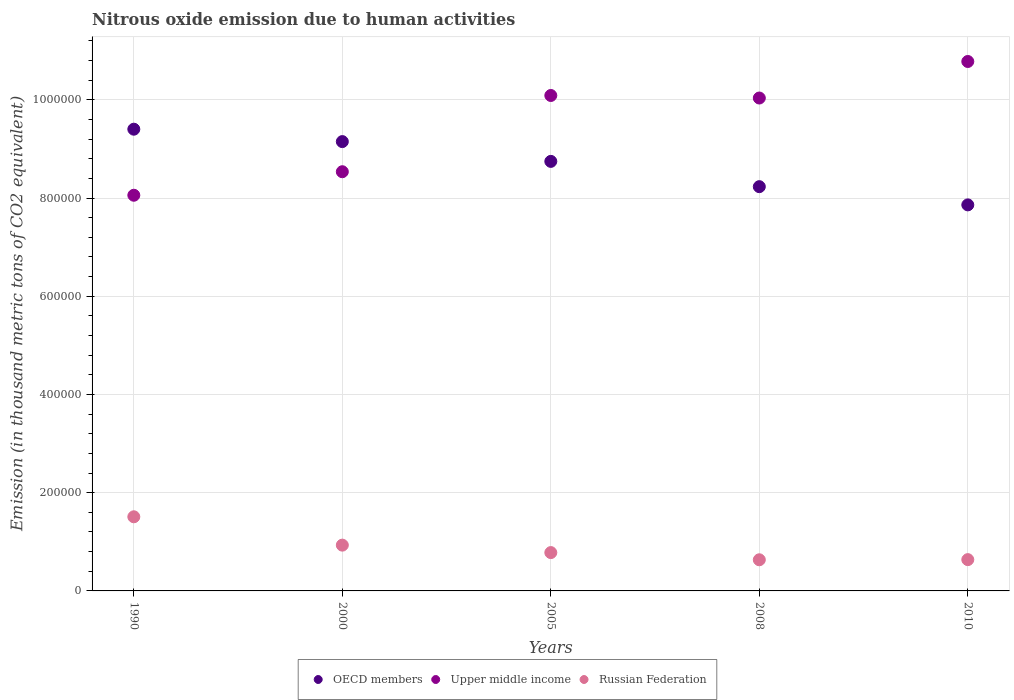What is the amount of nitrous oxide emitted in Russian Federation in 2000?
Offer a very short reply. 9.32e+04. Across all years, what is the maximum amount of nitrous oxide emitted in OECD members?
Your answer should be compact. 9.40e+05. Across all years, what is the minimum amount of nitrous oxide emitted in OECD members?
Keep it short and to the point. 7.86e+05. In which year was the amount of nitrous oxide emitted in Russian Federation maximum?
Ensure brevity in your answer.  1990. What is the total amount of nitrous oxide emitted in Russian Federation in the graph?
Offer a terse response. 4.49e+05. What is the difference between the amount of nitrous oxide emitted in Upper middle income in 2000 and that in 2010?
Offer a very short reply. -2.24e+05. What is the difference between the amount of nitrous oxide emitted in OECD members in 2000 and the amount of nitrous oxide emitted in Upper middle income in 2008?
Offer a terse response. -8.87e+04. What is the average amount of nitrous oxide emitted in Russian Federation per year?
Keep it short and to the point. 8.99e+04. In the year 2008, what is the difference between the amount of nitrous oxide emitted in Russian Federation and amount of nitrous oxide emitted in Upper middle income?
Provide a short and direct response. -9.40e+05. In how many years, is the amount of nitrous oxide emitted in Upper middle income greater than 240000 thousand metric tons?
Ensure brevity in your answer.  5. What is the ratio of the amount of nitrous oxide emitted in OECD members in 1990 to that in 2000?
Offer a very short reply. 1.03. Is the amount of nitrous oxide emitted in Upper middle income in 2000 less than that in 2008?
Provide a short and direct response. Yes. What is the difference between the highest and the second highest amount of nitrous oxide emitted in Upper middle income?
Offer a terse response. 6.92e+04. What is the difference between the highest and the lowest amount of nitrous oxide emitted in Russian Federation?
Your answer should be compact. 8.75e+04. In how many years, is the amount of nitrous oxide emitted in OECD members greater than the average amount of nitrous oxide emitted in OECD members taken over all years?
Provide a succinct answer. 3. Is it the case that in every year, the sum of the amount of nitrous oxide emitted in Russian Federation and amount of nitrous oxide emitted in OECD members  is greater than the amount of nitrous oxide emitted in Upper middle income?
Make the answer very short. No. Is the amount of nitrous oxide emitted in Upper middle income strictly greater than the amount of nitrous oxide emitted in OECD members over the years?
Give a very brief answer. No. How many dotlines are there?
Offer a very short reply. 3. Are the values on the major ticks of Y-axis written in scientific E-notation?
Provide a short and direct response. No. Does the graph contain any zero values?
Ensure brevity in your answer.  No. What is the title of the graph?
Provide a short and direct response. Nitrous oxide emission due to human activities. Does "Korea (Republic)" appear as one of the legend labels in the graph?
Provide a succinct answer. No. What is the label or title of the X-axis?
Offer a terse response. Years. What is the label or title of the Y-axis?
Your answer should be very brief. Emission (in thousand metric tons of CO2 equivalent). What is the Emission (in thousand metric tons of CO2 equivalent) in OECD members in 1990?
Your answer should be compact. 9.40e+05. What is the Emission (in thousand metric tons of CO2 equivalent) of Upper middle income in 1990?
Ensure brevity in your answer.  8.06e+05. What is the Emission (in thousand metric tons of CO2 equivalent) in Russian Federation in 1990?
Offer a terse response. 1.51e+05. What is the Emission (in thousand metric tons of CO2 equivalent) of OECD members in 2000?
Provide a short and direct response. 9.15e+05. What is the Emission (in thousand metric tons of CO2 equivalent) in Upper middle income in 2000?
Give a very brief answer. 8.54e+05. What is the Emission (in thousand metric tons of CO2 equivalent) of Russian Federation in 2000?
Your answer should be very brief. 9.32e+04. What is the Emission (in thousand metric tons of CO2 equivalent) in OECD members in 2005?
Make the answer very short. 8.75e+05. What is the Emission (in thousand metric tons of CO2 equivalent) in Upper middle income in 2005?
Give a very brief answer. 1.01e+06. What is the Emission (in thousand metric tons of CO2 equivalent) in Russian Federation in 2005?
Offer a very short reply. 7.81e+04. What is the Emission (in thousand metric tons of CO2 equivalent) in OECD members in 2008?
Keep it short and to the point. 8.23e+05. What is the Emission (in thousand metric tons of CO2 equivalent) of Upper middle income in 2008?
Ensure brevity in your answer.  1.00e+06. What is the Emission (in thousand metric tons of CO2 equivalent) of Russian Federation in 2008?
Provide a succinct answer. 6.34e+04. What is the Emission (in thousand metric tons of CO2 equivalent) in OECD members in 2010?
Provide a succinct answer. 7.86e+05. What is the Emission (in thousand metric tons of CO2 equivalent) in Upper middle income in 2010?
Ensure brevity in your answer.  1.08e+06. What is the Emission (in thousand metric tons of CO2 equivalent) of Russian Federation in 2010?
Your answer should be compact. 6.37e+04. Across all years, what is the maximum Emission (in thousand metric tons of CO2 equivalent) in OECD members?
Ensure brevity in your answer.  9.40e+05. Across all years, what is the maximum Emission (in thousand metric tons of CO2 equivalent) of Upper middle income?
Give a very brief answer. 1.08e+06. Across all years, what is the maximum Emission (in thousand metric tons of CO2 equivalent) of Russian Federation?
Keep it short and to the point. 1.51e+05. Across all years, what is the minimum Emission (in thousand metric tons of CO2 equivalent) in OECD members?
Give a very brief answer. 7.86e+05. Across all years, what is the minimum Emission (in thousand metric tons of CO2 equivalent) of Upper middle income?
Offer a very short reply. 8.06e+05. Across all years, what is the minimum Emission (in thousand metric tons of CO2 equivalent) in Russian Federation?
Ensure brevity in your answer.  6.34e+04. What is the total Emission (in thousand metric tons of CO2 equivalent) in OECD members in the graph?
Provide a short and direct response. 4.34e+06. What is the total Emission (in thousand metric tons of CO2 equivalent) of Upper middle income in the graph?
Give a very brief answer. 4.75e+06. What is the total Emission (in thousand metric tons of CO2 equivalent) in Russian Federation in the graph?
Make the answer very short. 4.49e+05. What is the difference between the Emission (in thousand metric tons of CO2 equivalent) of OECD members in 1990 and that in 2000?
Keep it short and to the point. 2.52e+04. What is the difference between the Emission (in thousand metric tons of CO2 equivalent) in Upper middle income in 1990 and that in 2000?
Provide a succinct answer. -4.79e+04. What is the difference between the Emission (in thousand metric tons of CO2 equivalent) in Russian Federation in 1990 and that in 2000?
Ensure brevity in your answer.  5.77e+04. What is the difference between the Emission (in thousand metric tons of CO2 equivalent) in OECD members in 1990 and that in 2005?
Make the answer very short. 6.55e+04. What is the difference between the Emission (in thousand metric tons of CO2 equivalent) in Upper middle income in 1990 and that in 2005?
Ensure brevity in your answer.  -2.03e+05. What is the difference between the Emission (in thousand metric tons of CO2 equivalent) of Russian Federation in 1990 and that in 2005?
Your response must be concise. 7.29e+04. What is the difference between the Emission (in thousand metric tons of CO2 equivalent) of OECD members in 1990 and that in 2008?
Offer a terse response. 1.17e+05. What is the difference between the Emission (in thousand metric tons of CO2 equivalent) in Upper middle income in 1990 and that in 2008?
Give a very brief answer. -1.98e+05. What is the difference between the Emission (in thousand metric tons of CO2 equivalent) of Russian Federation in 1990 and that in 2008?
Offer a very short reply. 8.75e+04. What is the difference between the Emission (in thousand metric tons of CO2 equivalent) in OECD members in 1990 and that in 2010?
Keep it short and to the point. 1.54e+05. What is the difference between the Emission (in thousand metric tons of CO2 equivalent) in Upper middle income in 1990 and that in 2010?
Your response must be concise. -2.72e+05. What is the difference between the Emission (in thousand metric tons of CO2 equivalent) of Russian Federation in 1990 and that in 2010?
Your answer should be compact. 8.72e+04. What is the difference between the Emission (in thousand metric tons of CO2 equivalent) of OECD members in 2000 and that in 2005?
Ensure brevity in your answer.  4.03e+04. What is the difference between the Emission (in thousand metric tons of CO2 equivalent) of Upper middle income in 2000 and that in 2005?
Make the answer very short. -1.55e+05. What is the difference between the Emission (in thousand metric tons of CO2 equivalent) of Russian Federation in 2000 and that in 2005?
Make the answer very short. 1.52e+04. What is the difference between the Emission (in thousand metric tons of CO2 equivalent) of OECD members in 2000 and that in 2008?
Make the answer very short. 9.18e+04. What is the difference between the Emission (in thousand metric tons of CO2 equivalent) in Upper middle income in 2000 and that in 2008?
Your answer should be very brief. -1.50e+05. What is the difference between the Emission (in thousand metric tons of CO2 equivalent) of Russian Federation in 2000 and that in 2008?
Your answer should be compact. 2.98e+04. What is the difference between the Emission (in thousand metric tons of CO2 equivalent) in OECD members in 2000 and that in 2010?
Ensure brevity in your answer.  1.29e+05. What is the difference between the Emission (in thousand metric tons of CO2 equivalent) in Upper middle income in 2000 and that in 2010?
Provide a succinct answer. -2.24e+05. What is the difference between the Emission (in thousand metric tons of CO2 equivalent) in Russian Federation in 2000 and that in 2010?
Ensure brevity in your answer.  2.95e+04. What is the difference between the Emission (in thousand metric tons of CO2 equivalent) of OECD members in 2005 and that in 2008?
Provide a short and direct response. 5.15e+04. What is the difference between the Emission (in thousand metric tons of CO2 equivalent) of Upper middle income in 2005 and that in 2008?
Your answer should be compact. 5159.9. What is the difference between the Emission (in thousand metric tons of CO2 equivalent) in Russian Federation in 2005 and that in 2008?
Keep it short and to the point. 1.46e+04. What is the difference between the Emission (in thousand metric tons of CO2 equivalent) in OECD members in 2005 and that in 2010?
Make the answer very short. 8.86e+04. What is the difference between the Emission (in thousand metric tons of CO2 equivalent) in Upper middle income in 2005 and that in 2010?
Give a very brief answer. -6.92e+04. What is the difference between the Emission (in thousand metric tons of CO2 equivalent) of Russian Federation in 2005 and that in 2010?
Provide a short and direct response. 1.43e+04. What is the difference between the Emission (in thousand metric tons of CO2 equivalent) of OECD members in 2008 and that in 2010?
Your answer should be very brief. 3.71e+04. What is the difference between the Emission (in thousand metric tons of CO2 equivalent) of Upper middle income in 2008 and that in 2010?
Give a very brief answer. -7.44e+04. What is the difference between the Emission (in thousand metric tons of CO2 equivalent) of Russian Federation in 2008 and that in 2010?
Offer a terse response. -319.3. What is the difference between the Emission (in thousand metric tons of CO2 equivalent) in OECD members in 1990 and the Emission (in thousand metric tons of CO2 equivalent) in Upper middle income in 2000?
Your answer should be compact. 8.66e+04. What is the difference between the Emission (in thousand metric tons of CO2 equivalent) in OECD members in 1990 and the Emission (in thousand metric tons of CO2 equivalent) in Russian Federation in 2000?
Offer a very short reply. 8.47e+05. What is the difference between the Emission (in thousand metric tons of CO2 equivalent) in Upper middle income in 1990 and the Emission (in thousand metric tons of CO2 equivalent) in Russian Federation in 2000?
Your answer should be very brief. 7.12e+05. What is the difference between the Emission (in thousand metric tons of CO2 equivalent) in OECD members in 1990 and the Emission (in thousand metric tons of CO2 equivalent) in Upper middle income in 2005?
Ensure brevity in your answer.  -6.86e+04. What is the difference between the Emission (in thousand metric tons of CO2 equivalent) of OECD members in 1990 and the Emission (in thousand metric tons of CO2 equivalent) of Russian Federation in 2005?
Ensure brevity in your answer.  8.62e+05. What is the difference between the Emission (in thousand metric tons of CO2 equivalent) of Upper middle income in 1990 and the Emission (in thousand metric tons of CO2 equivalent) of Russian Federation in 2005?
Your answer should be very brief. 7.28e+05. What is the difference between the Emission (in thousand metric tons of CO2 equivalent) of OECD members in 1990 and the Emission (in thousand metric tons of CO2 equivalent) of Upper middle income in 2008?
Provide a short and direct response. -6.35e+04. What is the difference between the Emission (in thousand metric tons of CO2 equivalent) of OECD members in 1990 and the Emission (in thousand metric tons of CO2 equivalent) of Russian Federation in 2008?
Your response must be concise. 8.77e+05. What is the difference between the Emission (in thousand metric tons of CO2 equivalent) of Upper middle income in 1990 and the Emission (in thousand metric tons of CO2 equivalent) of Russian Federation in 2008?
Offer a terse response. 7.42e+05. What is the difference between the Emission (in thousand metric tons of CO2 equivalent) of OECD members in 1990 and the Emission (in thousand metric tons of CO2 equivalent) of Upper middle income in 2010?
Provide a short and direct response. -1.38e+05. What is the difference between the Emission (in thousand metric tons of CO2 equivalent) in OECD members in 1990 and the Emission (in thousand metric tons of CO2 equivalent) in Russian Federation in 2010?
Your response must be concise. 8.76e+05. What is the difference between the Emission (in thousand metric tons of CO2 equivalent) of Upper middle income in 1990 and the Emission (in thousand metric tons of CO2 equivalent) of Russian Federation in 2010?
Offer a very short reply. 7.42e+05. What is the difference between the Emission (in thousand metric tons of CO2 equivalent) of OECD members in 2000 and the Emission (in thousand metric tons of CO2 equivalent) of Upper middle income in 2005?
Offer a very short reply. -9.39e+04. What is the difference between the Emission (in thousand metric tons of CO2 equivalent) in OECD members in 2000 and the Emission (in thousand metric tons of CO2 equivalent) in Russian Federation in 2005?
Make the answer very short. 8.37e+05. What is the difference between the Emission (in thousand metric tons of CO2 equivalent) of Upper middle income in 2000 and the Emission (in thousand metric tons of CO2 equivalent) of Russian Federation in 2005?
Your response must be concise. 7.76e+05. What is the difference between the Emission (in thousand metric tons of CO2 equivalent) of OECD members in 2000 and the Emission (in thousand metric tons of CO2 equivalent) of Upper middle income in 2008?
Provide a succinct answer. -8.87e+04. What is the difference between the Emission (in thousand metric tons of CO2 equivalent) of OECD members in 2000 and the Emission (in thousand metric tons of CO2 equivalent) of Russian Federation in 2008?
Make the answer very short. 8.51e+05. What is the difference between the Emission (in thousand metric tons of CO2 equivalent) of Upper middle income in 2000 and the Emission (in thousand metric tons of CO2 equivalent) of Russian Federation in 2008?
Provide a succinct answer. 7.90e+05. What is the difference between the Emission (in thousand metric tons of CO2 equivalent) of OECD members in 2000 and the Emission (in thousand metric tons of CO2 equivalent) of Upper middle income in 2010?
Ensure brevity in your answer.  -1.63e+05. What is the difference between the Emission (in thousand metric tons of CO2 equivalent) in OECD members in 2000 and the Emission (in thousand metric tons of CO2 equivalent) in Russian Federation in 2010?
Ensure brevity in your answer.  8.51e+05. What is the difference between the Emission (in thousand metric tons of CO2 equivalent) in Upper middle income in 2000 and the Emission (in thousand metric tons of CO2 equivalent) in Russian Federation in 2010?
Offer a very short reply. 7.90e+05. What is the difference between the Emission (in thousand metric tons of CO2 equivalent) of OECD members in 2005 and the Emission (in thousand metric tons of CO2 equivalent) of Upper middle income in 2008?
Your response must be concise. -1.29e+05. What is the difference between the Emission (in thousand metric tons of CO2 equivalent) of OECD members in 2005 and the Emission (in thousand metric tons of CO2 equivalent) of Russian Federation in 2008?
Provide a short and direct response. 8.11e+05. What is the difference between the Emission (in thousand metric tons of CO2 equivalent) in Upper middle income in 2005 and the Emission (in thousand metric tons of CO2 equivalent) in Russian Federation in 2008?
Make the answer very short. 9.45e+05. What is the difference between the Emission (in thousand metric tons of CO2 equivalent) in OECD members in 2005 and the Emission (in thousand metric tons of CO2 equivalent) in Upper middle income in 2010?
Your response must be concise. -2.03e+05. What is the difference between the Emission (in thousand metric tons of CO2 equivalent) of OECD members in 2005 and the Emission (in thousand metric tons of CO2 equivalent) of Russian Federation in 2010?
Make the answer very short. 8.11e+05. What is the difference between the Emission (in thousand metric tons of CO2 equivalent) of Upper middle income in 2005 and the Emission (in thousand metric tons of CO2 equivalent) of Russian Federation in 2010?
Your answer should be compact. 9.45e+05. What is the difference between the Emission (in thousand metric tons of CO2 equivalent) of OECD members in 2008 and the Emission (in thousand metric tons of CO2 equivalent) of Upper middle income in 2010?
Your response must be concise. -2.55e+05. What is the difference between the Emission (in thousand metric tons of CO2 equivalent) of OECD members in 2008 and the Emission (in thousand metric tons of CO2 equivalent) of Russian Federation in 2010?
Ensure brevity in your answer.  7.59e+05. What is the difference between the Emission (in thousand metric tons of CO2 equivalent) of Upper middle income in 2008 and the Emission (in thousand metric tons of CO2 equivalent) of Russian Federation in 2010?
Offer a terse response. 9.40e+05. What is the average Emission (in thousand metric tons of CO2 equivalent) of OECD members per year?
Make the answer very short. 8.68e+05. What is the average Emission (in thousand metric tons of CO2 equivalent) of Upper middle income per year?
Offer a very short reply. 9.50e+05. What is the average Emission (in thousand metric tons of CO2 equivalent) of Russian Federation per year?
Provide a short and direct response. 8.99e+04. In the year 1990, what is the difference between the Emission (in thousand metric tons of CO2 equivalent) in OECD members and Emission (in thousand metric tons of CO2 equivalent) in Upper middle income?
Keep it short and to the point. 1.34e+05. In the year 1990, what is the difference between the Emission (in thousand metric tons of CO2 equivalent) of OECD members and Emission (in thousand metric tons of CO2 equivalent) of Russian Federation?
Provide a short and direct response. 7.89e+05. In the year 1990, what is the difference between the Emission (in thousand metric tons of CO2 equivalent) of Upper middle income and Emission (in thousand metric tons of CO2 equivalent) of Russian Federation?
Keep it short and to the point. 6.55e+05. In the year 2000, what is the difference between the Emission (in thousand metric tons of CO2 equivalent) of OECD members and Emission (in thousand metric tons of CO2 equivalent) of Upper middle income?
Your answer should be very brief. 6.13e+04. In the year 2000, what is the difference between the Emission (in thousand metric tons of CO2 equivalent) in OECD members and Emission (in thousand metric tons of CO2 equivalent) in Russian Federation?
Offer a terse response. 8.22e+05. In the year 2000, what is the difference between the Emission (in thousand metric tons of CO2 equivalent) in Upper middle income and Emission (in thousand metric tons of CO2 equivalent) in Russian Federation?
Provide a succinct answer. 7.60e+05. In the year 2005, what is the difference between the Emission (in thousand metric tons of CO2 equivalent) in OECD members and Emission (in thousand metric tons of CO2 equivalent) in Upper middle income?
Provide a succinct answer. -1.34e+05. In the year 2005, what is the difference between the Emission (in thousand metric tons of CO2 equivalent) of OECD members and Emission (in thousand metric tons of CO2 equivalent) of Russian Federation?
Keep it short and to the point. 7.97e+05. In the year 2005, what is the difference between the Emission (in thousand metric tons of CO2 equivalent) of Upper middle income and Emission (in thousand metric tons of CO2 equivalent) of Russian Federation?
Keep it short and to the point. 9.31e+05. In the year 2008, what is the difference between the Emission (in thousand metric tons of CO2 equivalent) in OECD members and Emission (in thousand metric tons of CO2 equivalent) in Upper middle income?
Provide a short and direct response. -1.80e+05. In the year 2008, what is the difference between the Emission (in thousand metric tons of CO2 equivalent) in OECD members and Emission (in thousand metric tons of CO2 equivalent) in Russian Federation?
Offer a terse response. 7.60e+05. In the year 2008, what is the difference between the Emission (in thousand metric tons of CO2 equivalent) of Upper middle income and Emission (in thousand metric tons of CO2 equivalent) of Russian Federation?
Your answer should be very brief. 9.40e+05. In the year 2010, what is the difference between the Emission (in thousand metric tons of CO2 equivalent) in OECD members and Emission (in thousand metric tons of CO2 equivalent) in Upper middle income?
Give a very brief answer. -2.92e+05. In the year 2010, what is the difference between the Emission (in thousand metric tons of CO2 equivalent) in OECD members and Emission (in thousand metric tons of CO2 equivalent) in Russian Federation?
Provide a succinct answer. 7.22e+05. In the year 2010, what is the difference between the Emission (in thousand metric tons of CO2 equivalent) in Upper middle income and Emission (in thousand metric tons of CO2 equivalent) in Russian Federation?
Give a very brief answer. 1.01e+06. What is the ratio of the Emission (in thousand metric tons of CO2 equivalent) in OECD members in 1990 to that in 2000?
Keep it short and to the point. 1.03. What is the ratio of the Emission (in thousand metric tons of CO2 equivalent) in Upper middle income in 1990 to that in 2000?
Provide a short and direct response. 0.94. What is the ratio of the Emission (in thousand metric tons of CO2 equivalent) of Russian Federation in 1990 to that in 2000?
Provide a succinct answer. 1.62. What is the ratio of the Emission (in thousand metric tons of CO2 equivalent) of OECD members in 1990 to that in 2005?
Offer a terse response. 1.07. What is the ratio of the Emission (in thousand metric tons of CO2 equivalent) in Upper middle income in 1990 to that in 2005?
Provide a succinct answer. 0.8. What is the ratio of the Emission (in thousand metric tons of CO2 equivalent) of Russian Federation in 1990 to that in 2005?
Your answer should be compact. 1.93. What is the ratio of the Emission (in thousand metric tons of CO2 equivalent) in OECD members in 1990 to that in 2008?
Offer a terse response. 1.14. What is the ratio of the Emission (in thousand metric tons of CO2 equivalent) of Upper middle income in 1990 to that in 2008?
Your answer should be very brief. 0.8. What is the ratio of the Emission (in thousand metric tons of CO2 equivalent) of Russian Federation in 1990 to that in 2008?
Your response must be concise. 2.38. What is the ratio of the Emission (in thousand metric tons of CO2 equivalent) in OECD members in 1990 to that in 2010?
Ensure brevity in your answer.  1.2. What is the ratio of the Emission (in thousand metric tons of CO2 equivalent) in Upper middle income in 1990 to that in 2010?
Offer a very short reply. 0.75. What is the ratio of the Emission (in thousand metric tons of CO2 equivalent) in Russian Federation in 1990 to that in 2010?
Give a very brief answer. 2.37. What is the ratio of the Emission (in thousand metric tons of CO2 equivalent) of OECD members in 2000 to that in 2005?
Ensure brevity in your answer.  1.05. What is the ratio of the Emission (in thousand metric tons of CO2 equivalent) in Upper middle income in 2000 to that in 2005?
Your response must be concise. 0.85. What is the ratio of the Emission (in thousand metric tons of CO2 equivalent) in Russian Federation in 2000 to that in 2005?
Your answer should be compact. 1.19. What is the ratio of the Emission (in thousand metric tons of CO2 equivalent) in OECD members in 2000 to that in 2008?
Your answer should be very brief. 1.11. What is the ratio of the Emission (in thousand metric tons of CO2 equivalent) of Upper middle income in 2000 to that in 2008?
Keep it short and to the point. 0.85. What is the ratio of the Emission (in thousand metric tons of CO2 equivalent) in Russian Federation in 2000 to that in 2008?
Provide a succinct answer. 1.47. What is the ratio of the Emission (in thousand metric tons of CO2 equivalent) of OECD members in 2000 to that in 2010?
Your answer should be very brief. 1.16. What is the ratio of the Emission (in thousand metric tons of CO2 equivalent) of Upper middle income in 2000 to that in 2010?
Your answer should be compact. 0.79. What is the ratio of the Emission (in thousand metric tons of CO2 equivalent) in Russian Federation in 2000 to that in 2010?
Offer a very short reply. 1.46. What is the ratio of the Emission (in thousand metric tons of CO2 equivalent) of OECD members in 2005 to that in 2008?
Ensure brevity in your answer.  1.06. What is the ratio of the Emission (in thousand metric tons of CO2 equivalent) of Russian Federation in 2005 to that in 2008?
Offer a very short reply. 1.23. What is the ratio of the Emission (in thousand metric tons of CO2 equivalent) in OECD members in 2005 to that in 2010?
Your answer should be very brief. 1.11. What is the ratio of the Emission (in thousand metric tons of CO2 equivalent) of Upper middle income in 2005 to that in 2010?
Keep it short and to the point. 0.94. What is the ratio of the Emission (in thousand metric tons of CO2 equivalent) of Russian Federation in 2005 to that in 2010?
Provide a short and direct response. 1.22. What is the ratio of the Emission (in thousand metric tons of CO2 equivalent) in OECD members in 2008 to that in 2010?
Make the answer very short. 1.05. What is the ratio of the Emission (in thousand metric tons of CO2 equivalent) in Upper middle income in 2008 to that in 2010?
Offer a terse response. 0.93. What is the difference between the highest and the second highest Emission (in thousand metric tons of CO2 equivalent) in OECD members?
Keep it short and to the point. 2.52e+04. What is the difference between the highest and the second highest Emission (in thousand metric tons of CO2 equivalent) of Upper middle income?
Your answer should be compact. 6.92e+04. What is the difference between the highest and the second highest Emission (in thousand metric tons of CO2 equivalent) in Russian Federation?
Offer a very short reply. 5.77e+04. What is the difference between the highest and the lowest Emission (in thousand metric tons of CO2 equivalent) of OECD members?
Keep it short and to the point. 1.54e+05. What is the difference between the highest and the lowest Emission (in thousand metric tons of CO2 equivalent) of Upper middle income?
Your answer should be compact. 2.72e+05. What is the difference between the highest and the lowest Emission (in thousand metric tons of CO2 equivalent) of Russian Federation?
Your response must be concise. 8.75e+04. 